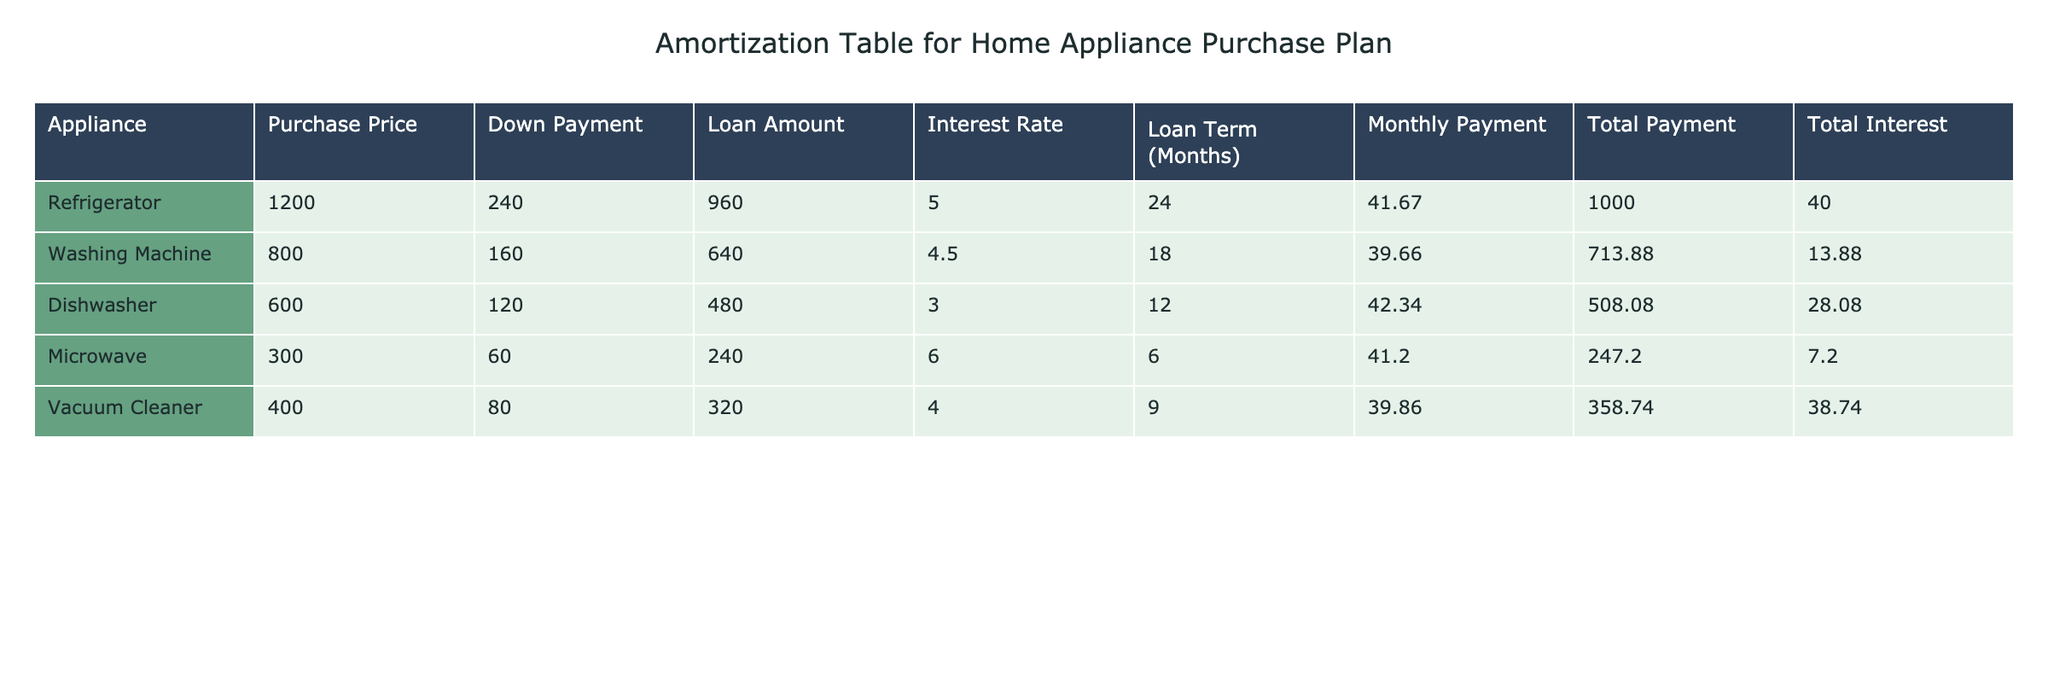What is the total payment for the Washing Machine? The table indicates that the total payment for the Washing Machine is listed directly under the "Total Payment" column, which is 713.88
Answer: 713.88 What was the loan amount for the Dishwasher? According to the table, the loan amount for the Dishwasher can be found in the "Loan Amount" column, which shows 480
Answer: 480 Which appliance has the highest total interest paid? By comparing the total interest figures in the "Total Interest" column, the Vacuum Cleaner has the highest total interest paid, which is 38.74
Answer: Vacuum Cleaner What is the average monthly payment for all the appliances? To find the average, we will sum the monthly payments (41.67 + 39.66 + 42.34 + 41.20 + 39.86 = 204.73) and divide by the number of appliances (5). So the average monthly payment is 204.73 / 5 = 40.946
Answer: 40.95 Is the interest rate for the Microwave higher than for the Dishwasher? The interest rate for the Microwave is 6.0 while for the Dishwasher it is 3.0. Since 6.0 is greater than 3.0, the statement is true
Answer: Yes What is the total interest paid across all appliances? First, sum the total interest amounts from the "Total Interest" column (40.00 + 13.88 + 28.08 + 7.20 + 38.74 = 127.90), thus the total interest paid across all appliances is 127.90
Answer: 127.90 How long is the loan term for the Refrigerator? Referring to the "Loan Term (Months)" column in the table, the loan term for the Refrigerator is 24 months
Answer: 24 months Which appliance has the lowest purchase price? By checking the "Purchase Price" column, the Dishwasher has the lowest purchase price listed at 600, compared to others
Answer: Dishwasher Is the monthly payment for the Vacuum Cleaner less than 40? The table shows that the monthly payment for the Vacuum Cleaner is 39.86, which is less than 40, making the statement true
Answer: Yes 